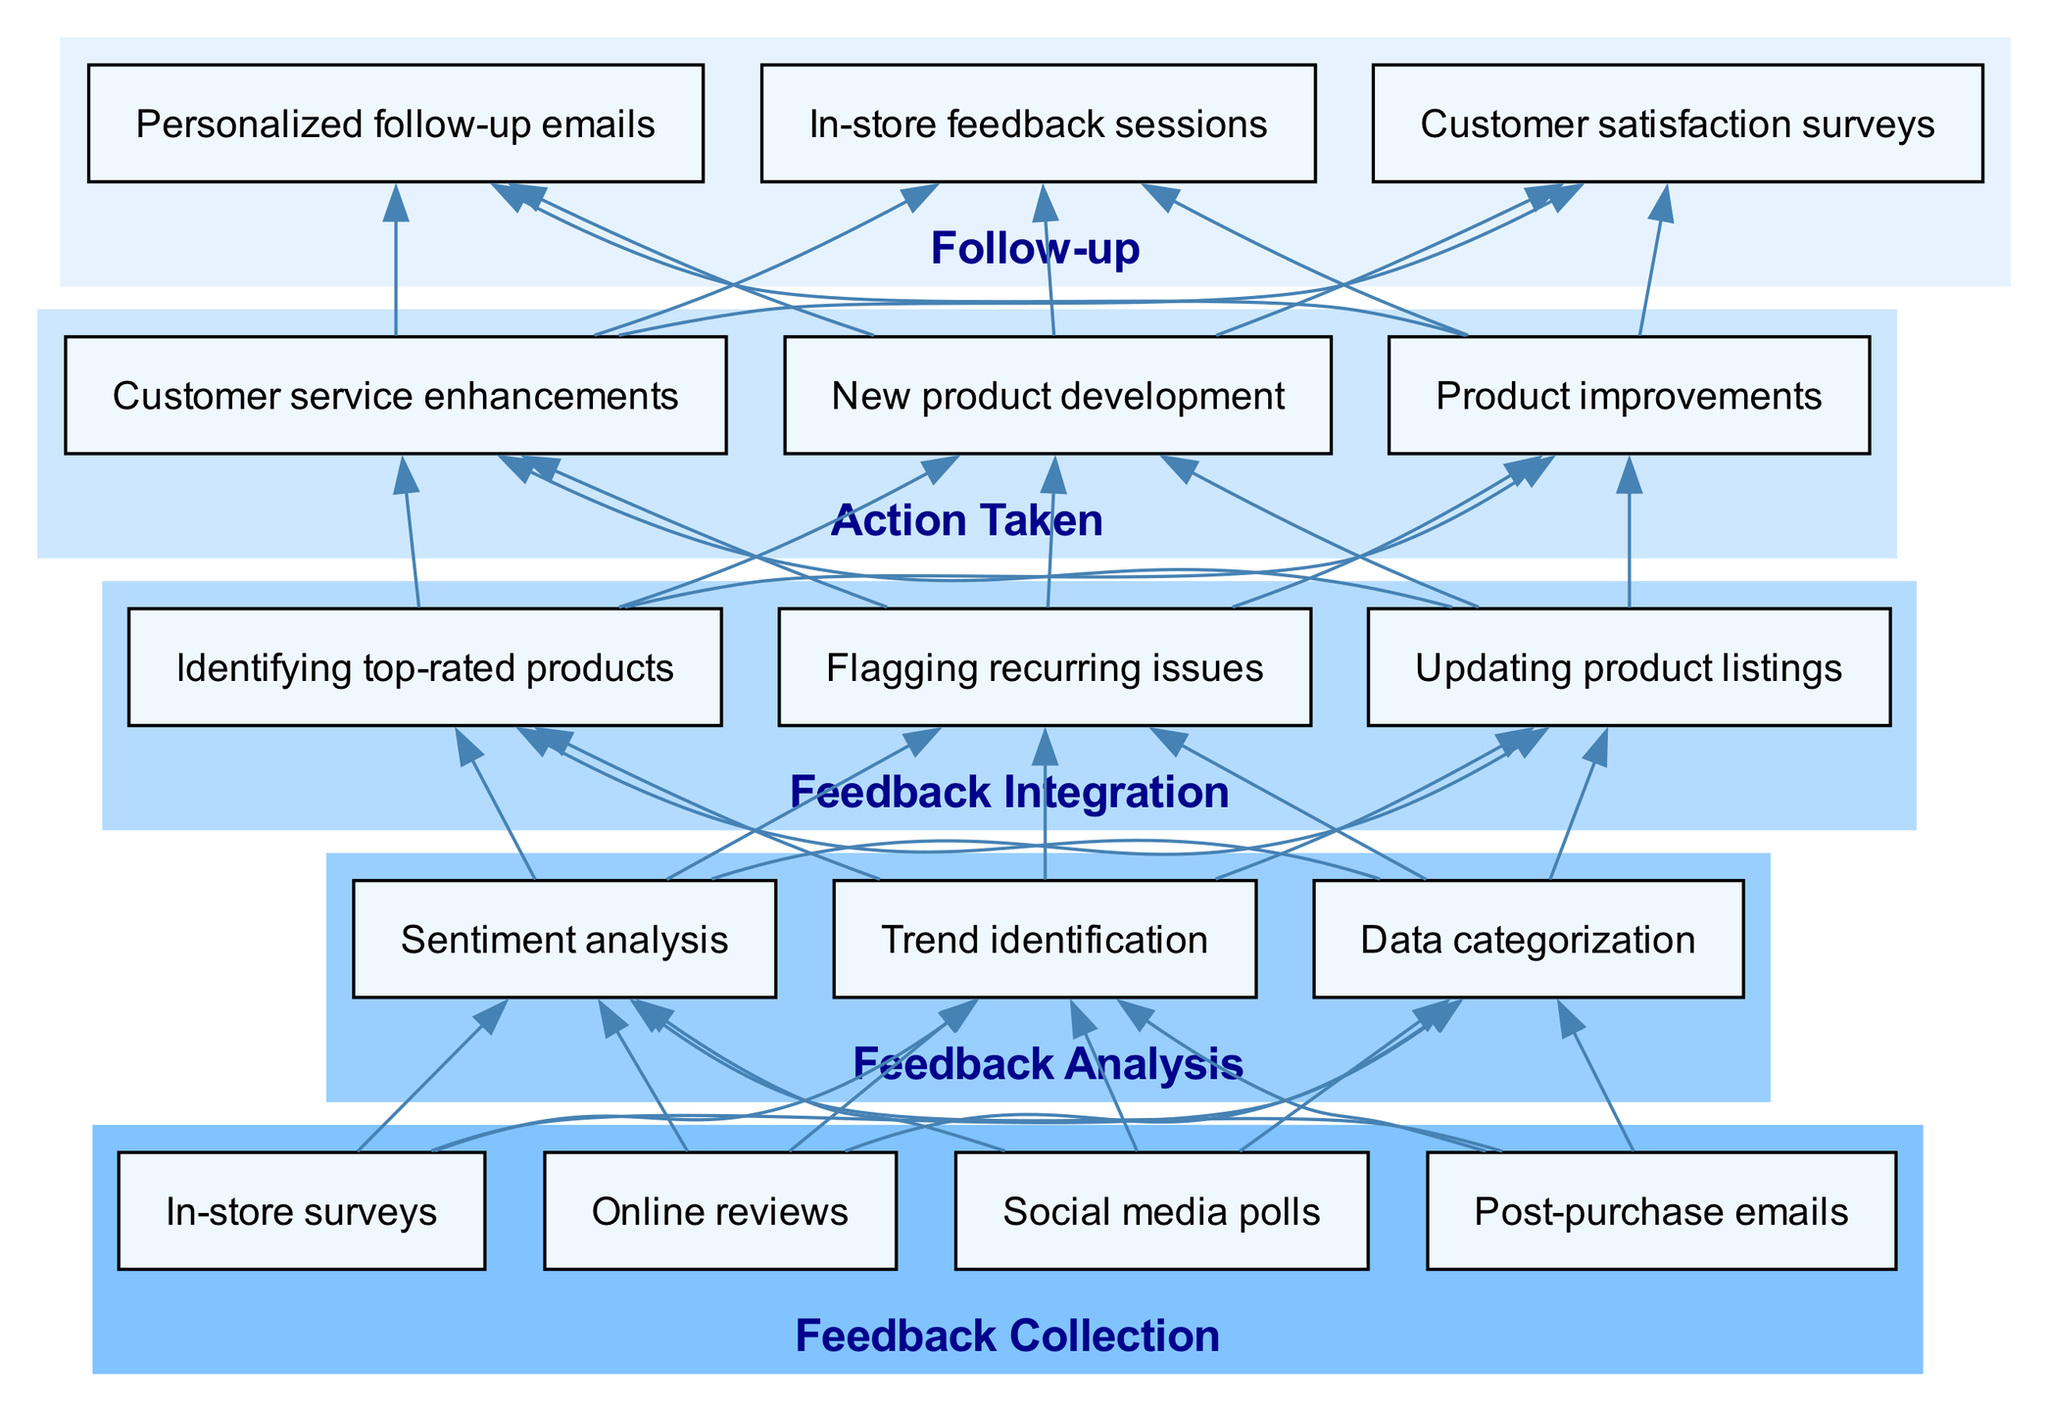What is the first stage in the feedback loop? The first stage is "Feedback Collection" as indicated at the bottom of the diagram layout.
Answer: Feedback Collection How many methods are listed under the Feedback Collection stage? There are four methods listed: "In-store surveys", "Online reviews", "Social media polls", and "Post-purchase emails".
Answer: 4 What is the last stage of the diagram? The last stage in the diagram is "Follow-up", which is at the top in the bottom-up flow structure.
Answer: Follow-up What action is related to the stage of Feedback Integration? The actions listed under Feedback Integration include "Updating product listings", "Identifying top-rated products", and "Flagging recurring issues".
Answer: Updating product listings Which stage precedes the Action Taken stage? The stage that precedes Action Taken is Feedback Integration, as seen when moving up the diagram from Action Taken.
Answer: Feedback Integration What outcome is associated with Action Taken? The outcomes associated with Action Taken include "Product improvements", "Customer service enhancements", and "New product development".
Answer: Product improvements Identify one method used for Follow-up. One of the methods listed under Follow-up is "Customer satisfaction surveys", which is clearly labeled within the stage section of the diagram.
Answer: Customer satisfaction surveys How many total stages are present in the Customer Feedback Loop? There are five stages in total as indicated in the diagram: Feedback Collection, Feedback Analysis, Feedback Integration, Action Taken, and Follow-up.
Answer: 5 Which process is included in the Feedback Analysis stage? The processes listed under Feedback Analysis include "Data categorization", "Sentiment analysis", and "Trend identification".
Answer: Sentiment analysis 